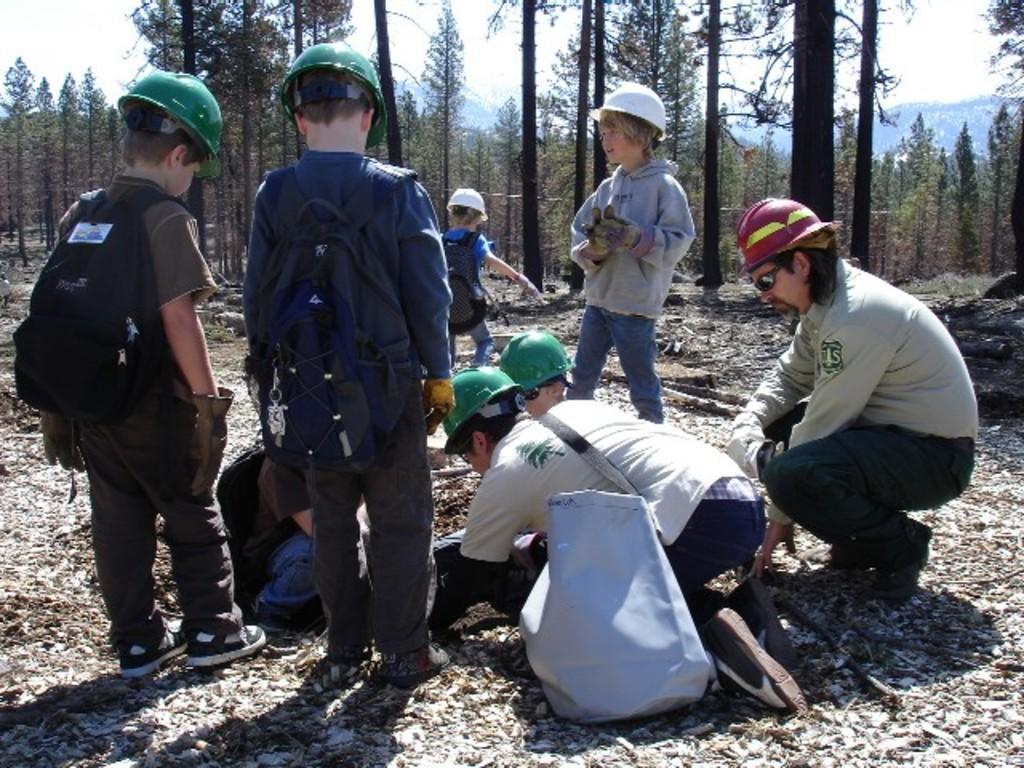Could you give a brief overview of what you see in this image? In this image I can see the group of people with different color dresses. I can see these people with green, white and red color helmets. Few people are holding the bags. In the background I can see many trees and the white sky. 